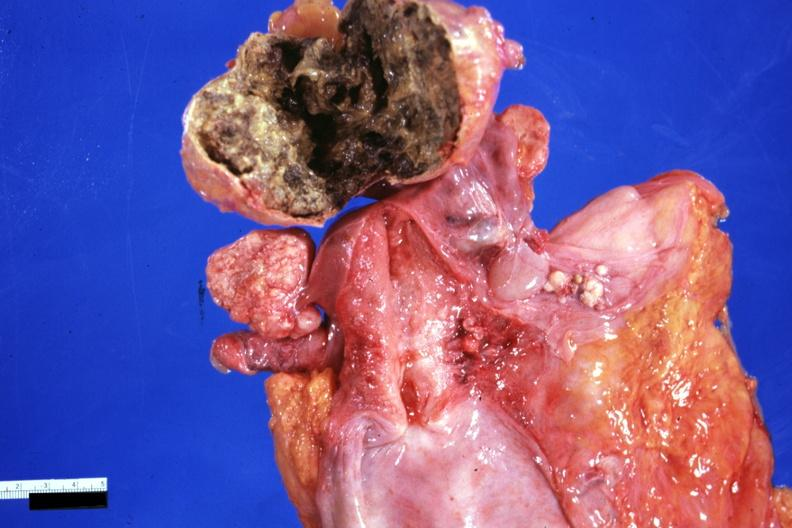what is present?
Answer the question using a single word or phrase. Ovary 